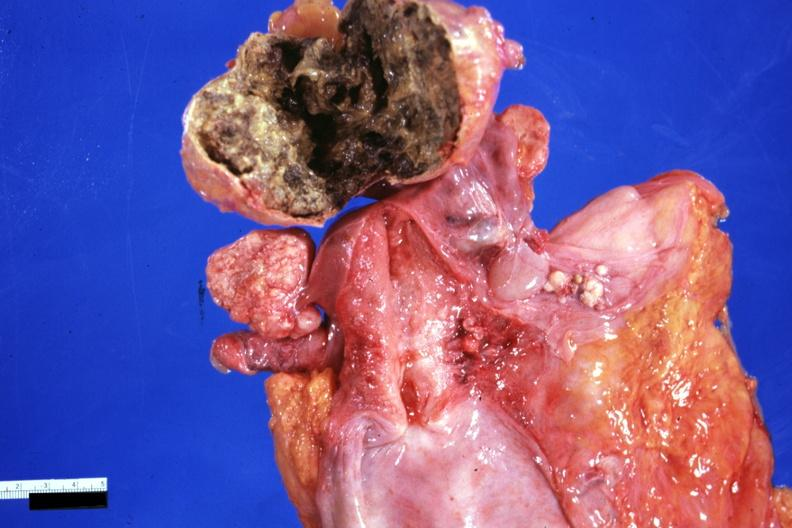what is present?
Answer the question using a single word or phrase. Ovary 